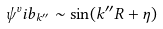Convert formula to latex. <formula><loc_0><loc_0><loc_500><loc_500>\psi ^ { v } i b _ { k ^ { \prime \prime } } \sim \sin ( k ^ { \prime \prime } R + \eta )</formula> 